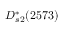<formula> <loc_0><loc_0><loc_500><loc_500>D _ { s 2 } ^ { * } ( 2 5 7 3 )</formula> 